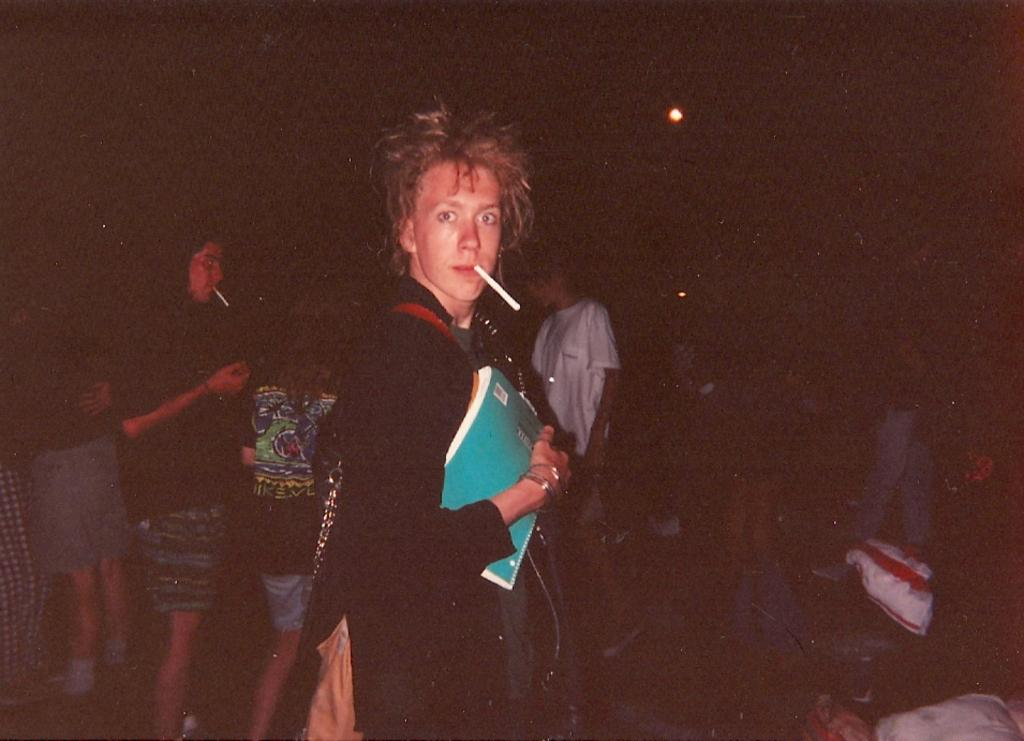Who is the main subject in the image? There is a person in the center of the image. What is the person holding in the image? The person is holding books. What is the person wearing in the image? The person is wearing a black dress. Can you describe the background of the image? The background is dark, and there are people standing in it. How many toothpaste tubes can be seen in the image? There are no toothpaste tubes present in the image. Is there a faucet visible in the image? There is no faucet visible in the image. 